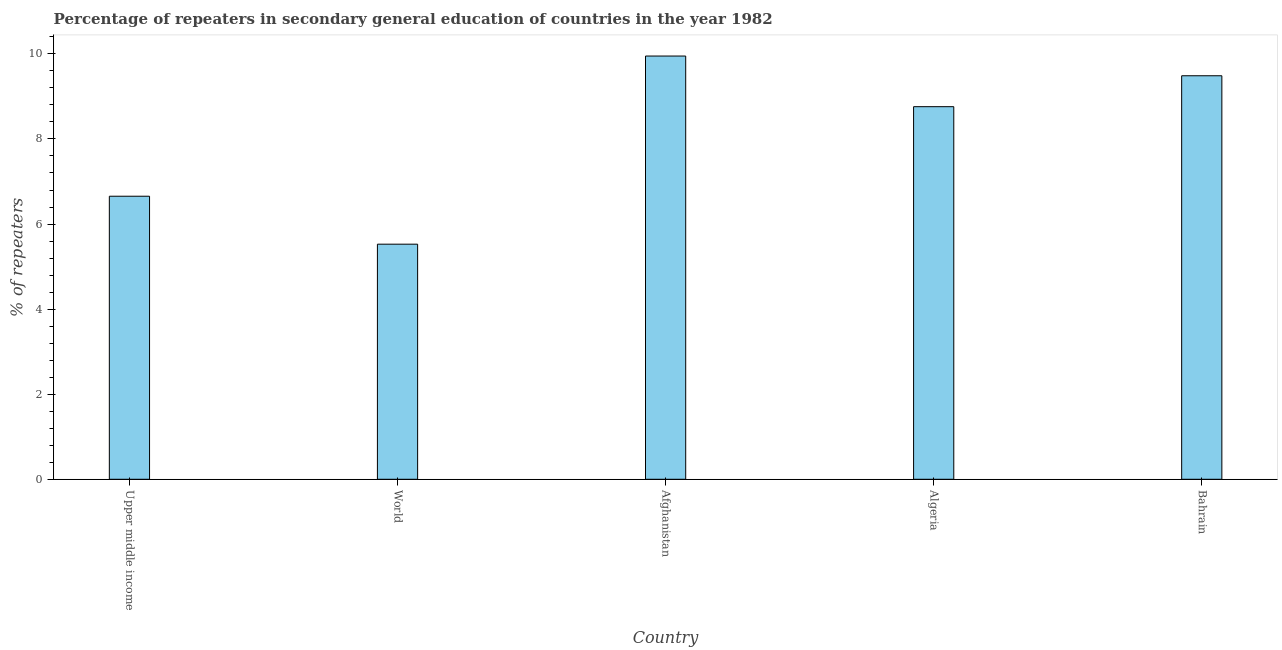Does the graph contain any zero values?
Make the answer very short. No. What is the title of the graph?
Your response must be concise. Percentage of repeaters in secondary general education of countries in the year 1982. What is the label or title of the Y-axis?
Make the answer very short. % of repeaters. What is the percentage of repeaters in Upper middle income?
Keep it short and to the point. 6.65. Across all countries, what is the maximum percentage of repeaters?
Offer a very short reply. 9.95. Across all countries, what is the minimum percentage of repeaters?
Make the answer very short. 5.53. In which country was the percentage of repeaters maximum?
Offer a very short reply. Afghanistan. In which country was the percentage of repeaters minimum?
Your response must be concise. World. What is the sum of the percentage of repeaters?
Provide a short and direct response. 40.37. What is the difference between the percentage of repeaters in Upper middle income and World?
Ensure brevity in your answer.  1.13. What is the average percentage of repeaters per country?
Provide a succinct answer. 8.07. What is the median percentage of repeaters?
Provide a succinct answer. 8.76. In how many countries, is the percentage of repeaters greater than 7.6 %?
Offer a terse response. 3. What is the ratio of the percentage of repeaters in Afghanistan to that in Upper middle income?
Provide a short and direct response. 1.5. Is the difference between the percentage of repeaters in Bahrain and World greater than the difference between any two countries?
Your response must be concise. No. What is the difference between the highest and the second highest percentage of repeaters?
Provide a short and direct response. 0.46. Is the sum of the percentage of repeaters in Algeria and Upper middle income greater than the maximum percentage of repeaters across all countries?
Your answer should be very brief. Yes. What is the difference between the highest and the lowest percentage of repeaters?
Offer a very short reply. 4.42. Are all the bars in the graph horizontal?
Give a very brief answer. No. How many countries are there in the graph?
Provide a succinct answer. 5. What is the difference between two consecutive major ticks on the Y-axis?
Provide a short and direct response. 2. What is the % of repeaters in Upper middle income?
Give a very brief answer. 6.65. What is the % of repeaters of World?
Provide a succinct answer. 5.53. What is the % of repeaters in Afghanistan?
Ensure brevity in your answer.  9.95. What is the % of repeaters of Algeria?
Offer a very short reply. 8.76. What is the % of repeaters in Bahrain?
Your response must be concise. 9.49. What is the difference between the % of repeaters in Upper middle income and World?
Offer a terse response. 1.13. What is the difference between the % of repeaters in Upper middle income and Afghanistan?
Ensure brevity in your answer.  -3.3. What is the difference between the % of repeaters in Upper middle income and Algeria?
Ensure brevity in your answer.  -2.11. What is the difference between the % of repeaters in Upper middle income and Bahrain?
Make the answer very short. -2.83. What is the difference between the % of repeaters in World and Afghanistan?
Offer a terse response. -4.42. What is the difference between the % of repeaters in World and Algeria?
Provide a succinct answer. -3.23. What is the difference between the % of repeaters in World and Bahrain?
Provide a short and direct response. -3.96. What is the difference between the % of repeaters in Afghanistan and Algeria?
Make the answer very short. 1.19. What is the difference between the % of repeaters in Afghanistan and Bahrain?
Your response must be concise. 0.46. What is the difference between the % of repeaters in Algeria and Bahrain?
Provide a succinct answer. -0.73. What is the ratio of the % of repeaters in Upper middle income to that in World?
Make the answer very short. 1.2. What is the ratio of the % of repeaters in Upper middle income to that in Afghanistan?
Your response must be concise. 0.67. What is the ratio of the % of repeaters in Upper middle income to that in Algeria?
Make the answer very short. 0.76. What is the ratio of the % of repeaters in Upper middle income to that in Bahrain?
Offer a terse response. 0.7. What is the ratio of the % of repeaters in World to that in Afghanistan?
Keep it short and to the point. 0.56. What is the ratio of the % of repeaters in World to that in Algeria?
Provide a succinct answer. 0.63. What is the ratio of the % of repeaters in World to that in Bahrain?
Provide a short and direct response. 0.58. What is the ratio of the % of repeaters in Afghanistan to that in Algeria?
Offer a terse response. 1.14. What is the ratio of the % of repeaters in Afghanistan to that in Bahrain?
Keep it short and to the point. 1.05. What is the ratio of the % of repeaters in Algeria to that in Bahrain?
Keep it short and to the point. 0.92. 